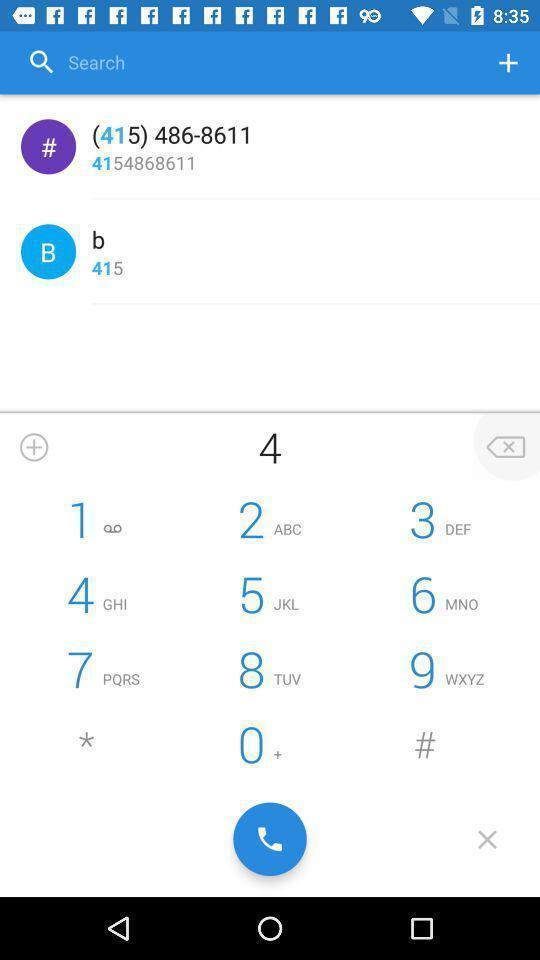Please provide a description for this image. Page displaying with keypad and with few options. 